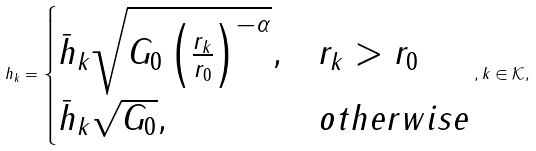<formula> <loc_0><loc_0><loc_500><loc_500>h _ { k } = \begin{cases} \bar { h } _ { k } \sqrt { G _ { 0 } \left ( \frac { r _ { k } } { r _ { 0 } } \right ) ^ { - \alpha } } , & r _ { k } > r _ { 0 } \\ \bar { h } _ { k } \sqrt { G _ { 0 } } , & o t h e r w i s e \end{cases} , k \in \mathcal { K } ,</formula> 